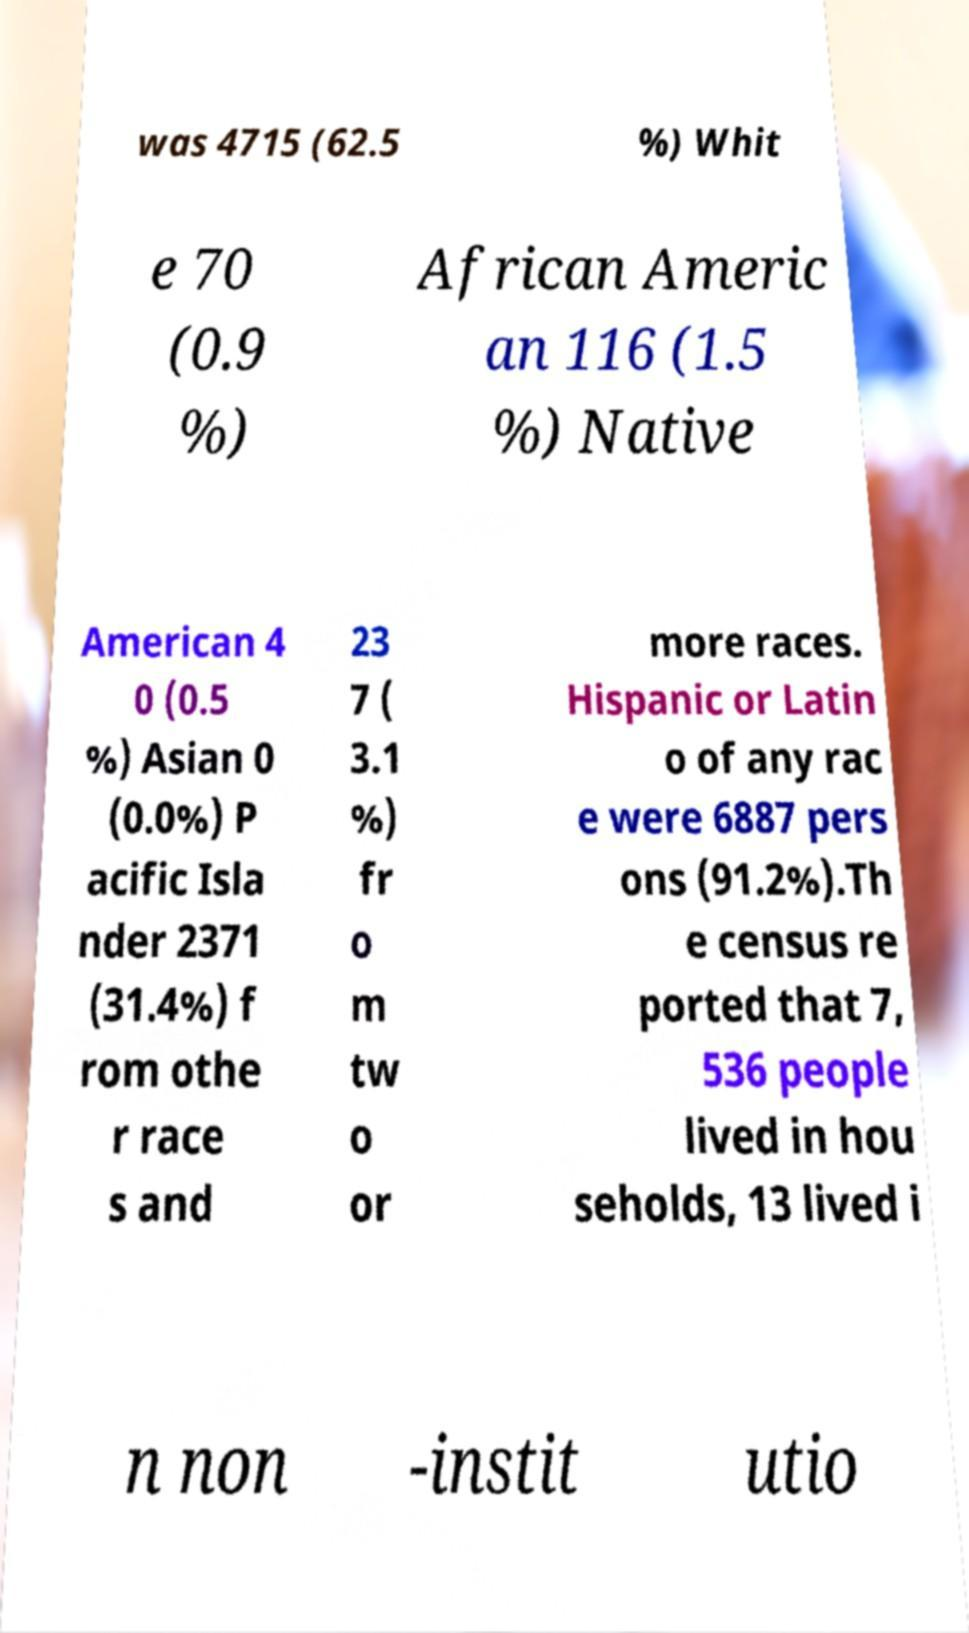Can you accurately transcribe the text from the provided image for me? was 4715 (62.5 %) Whit e 70 (0.9 %) African Americ an 116 (1.5 %) Native American 4 0 (0.5 %) Asian 0 (0.0%) P acific Isla nder 2371 (31.4%) f rom othe r race s and 23 7 ( 3.1 %) fr o m tw o or more races. Hispanic or Latin o of any rac e were 6887 pers ons (91.2%).Th e census re ported that 7, 536 people lived in hou seholds, 13 lived i n non -instit utio 